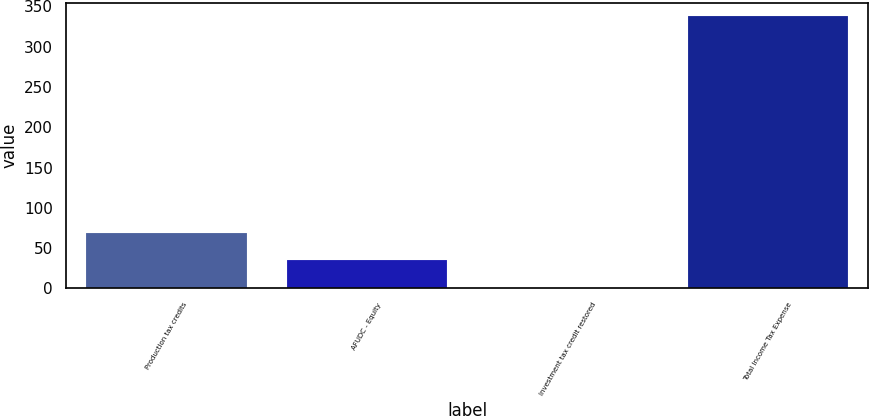<chart> <loc_0><loc_0><loc_500><loc_500><bar_chart><fcel>Production tax credits<fcel>AFUDC - Equity<fcel>Investment tax credit restored<fcel>Total Income Tax Expense<nl><fcel>68.46<fcel>34.78<fcel>1.1<fcel>337.9<nl></chart> 